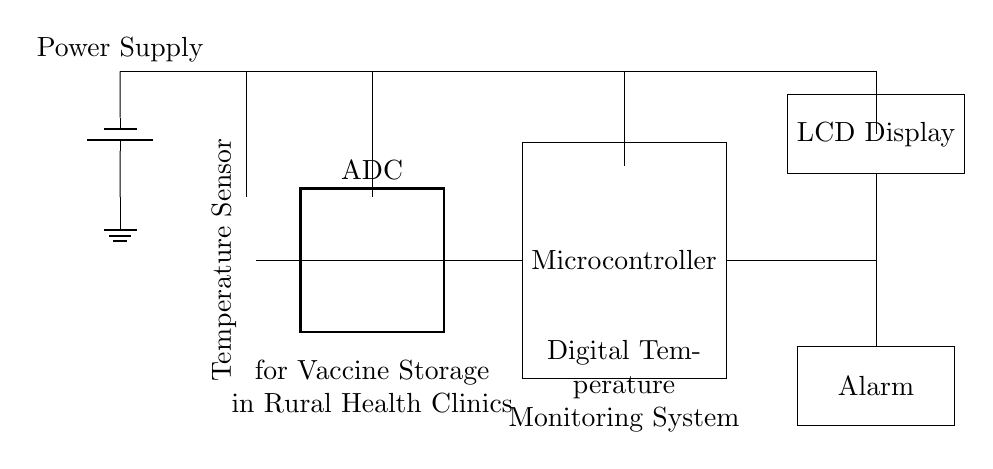What component measures temperature? The temperature sensor, represented by the thermistor symbol, is responsible for measuring the temperature within the vaccine storage environment.
Answer: Temperature Sensor What is the function of the ADC in this circuit? The Analog-to-Digital Converter (ADC) converts the analog signal from the temperature sensor into a digital signal that the microcontroller can process.
Answer: Converts analog to digital Which component displays the temperature readings? The LCD Display is used to present the current temperature readings to users in a readable format.
Answer: LCD Display What is the purpose of the alarm? The alarm is designed to alert users if the temperature exceeds or falls below preset thresholds, indicating potential issues with vaccine storage.
Answer: Alert users How does the microcontroller interact with the other components? The microcontroller receives data from the ADC, processes it, and sends it to the LCD Display for visual feedback while also controlling the alarm based on the temperature readings.
Answer: Controls temperature readings Which component provides power to the circuit? The battery serves as the power supply, energizing all the components in the digital temperature monitoring system.
Answer: Power Supply 